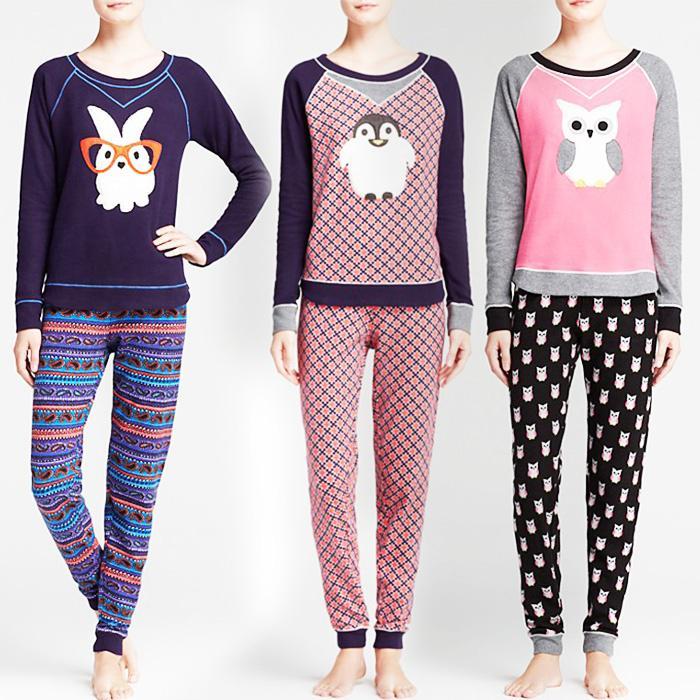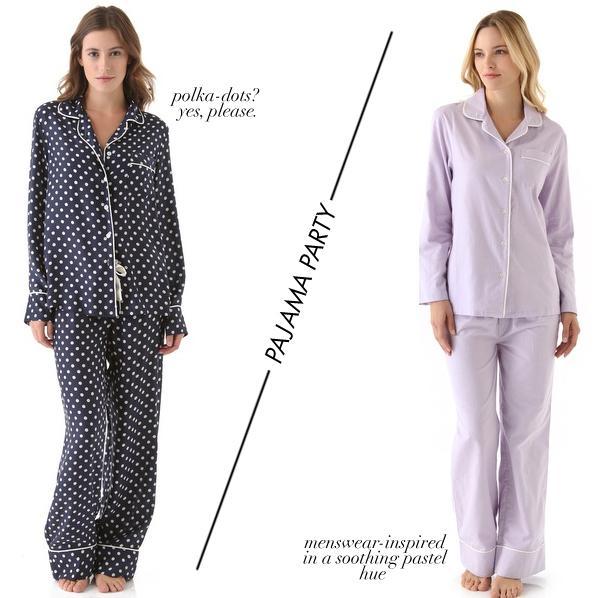The first image is the image on the left, the second image is the image on the right. Examine the images to the left and right. Is the description "An image shows three models side-by-side, all wearing long-legged loungewear." accurate? Answer yes or no. Yes. 